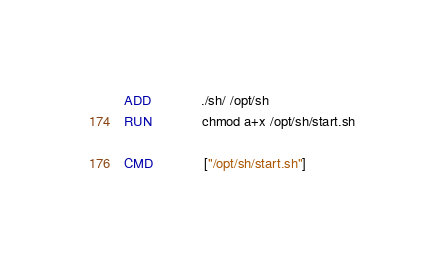<code> <loc_0><loc_0><loc_500><loc_500><_Dockerfile_>
ADD             ./sh/ /opt/sh
RUN             chmod a+x /opt/sh/start.sh

CMD             ["/opt/sh/start.sh"]
</code> 